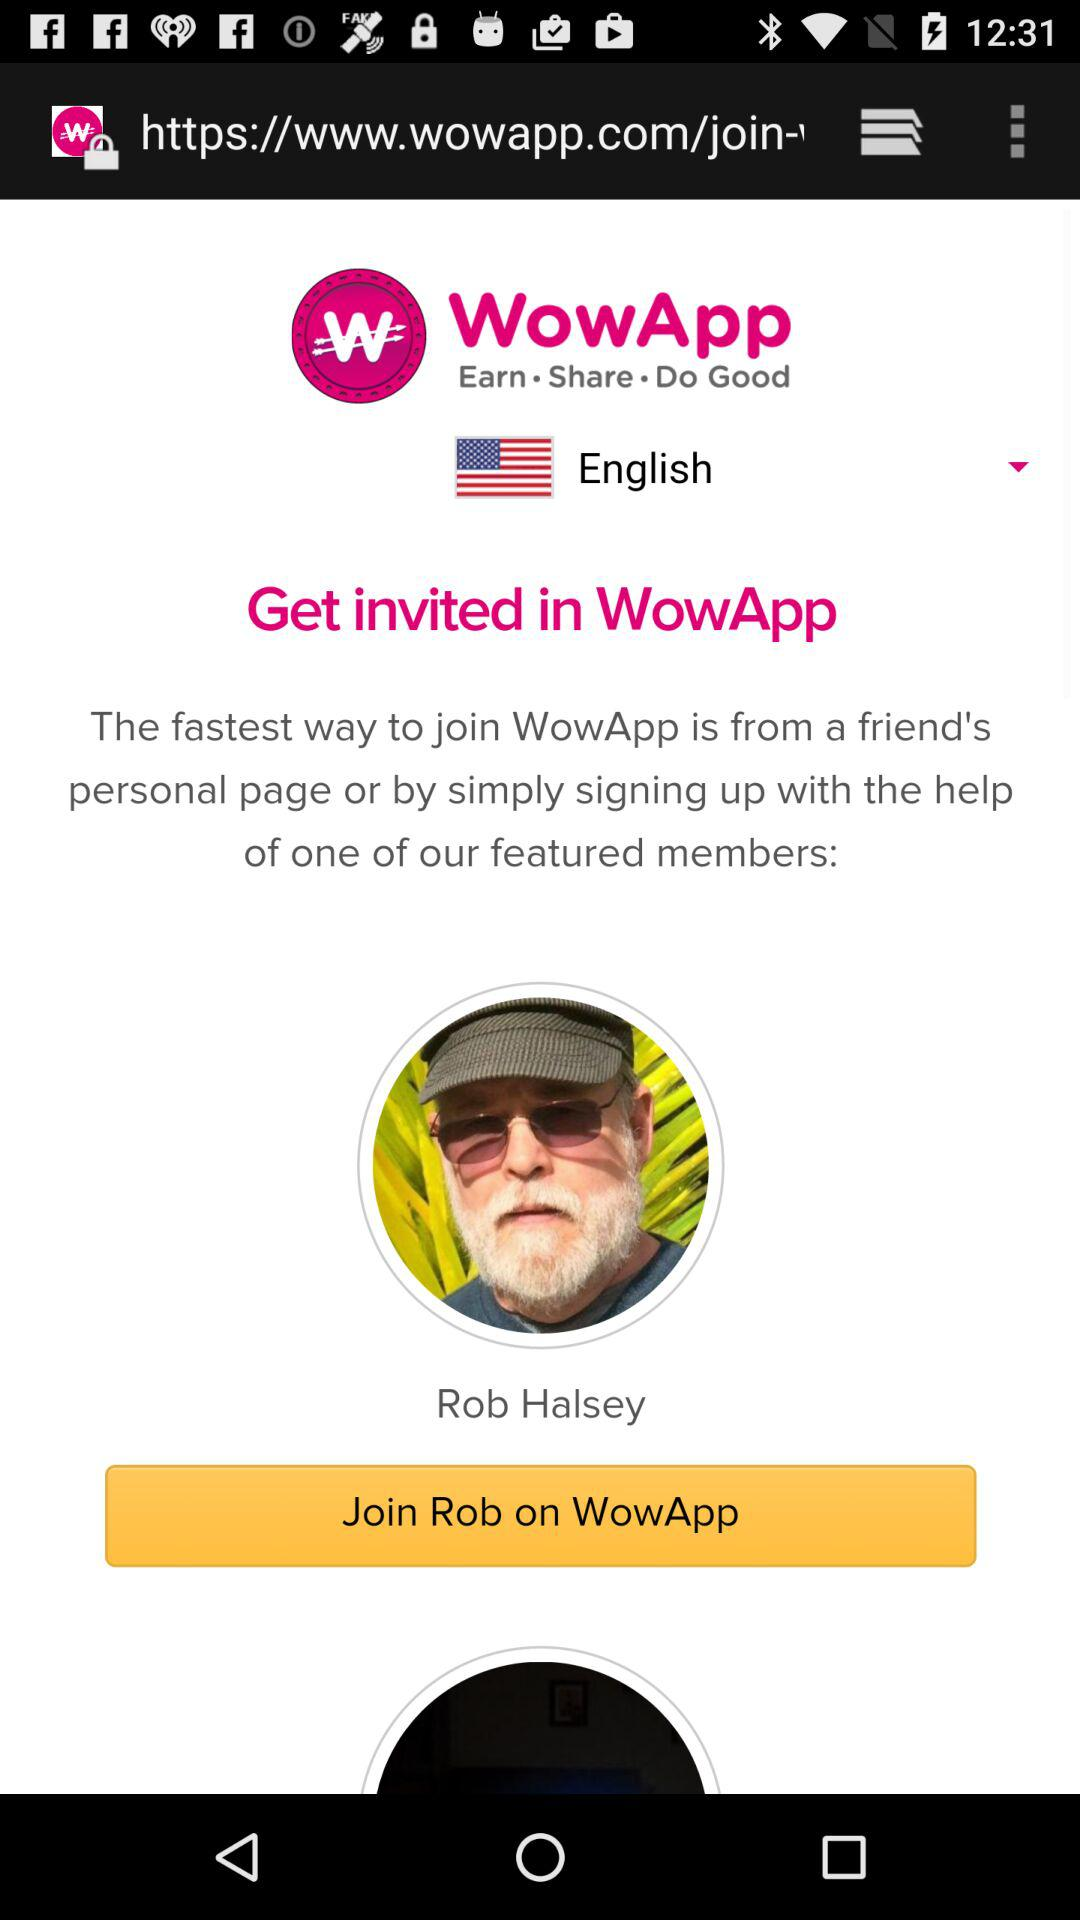What is the language? The language is English. 